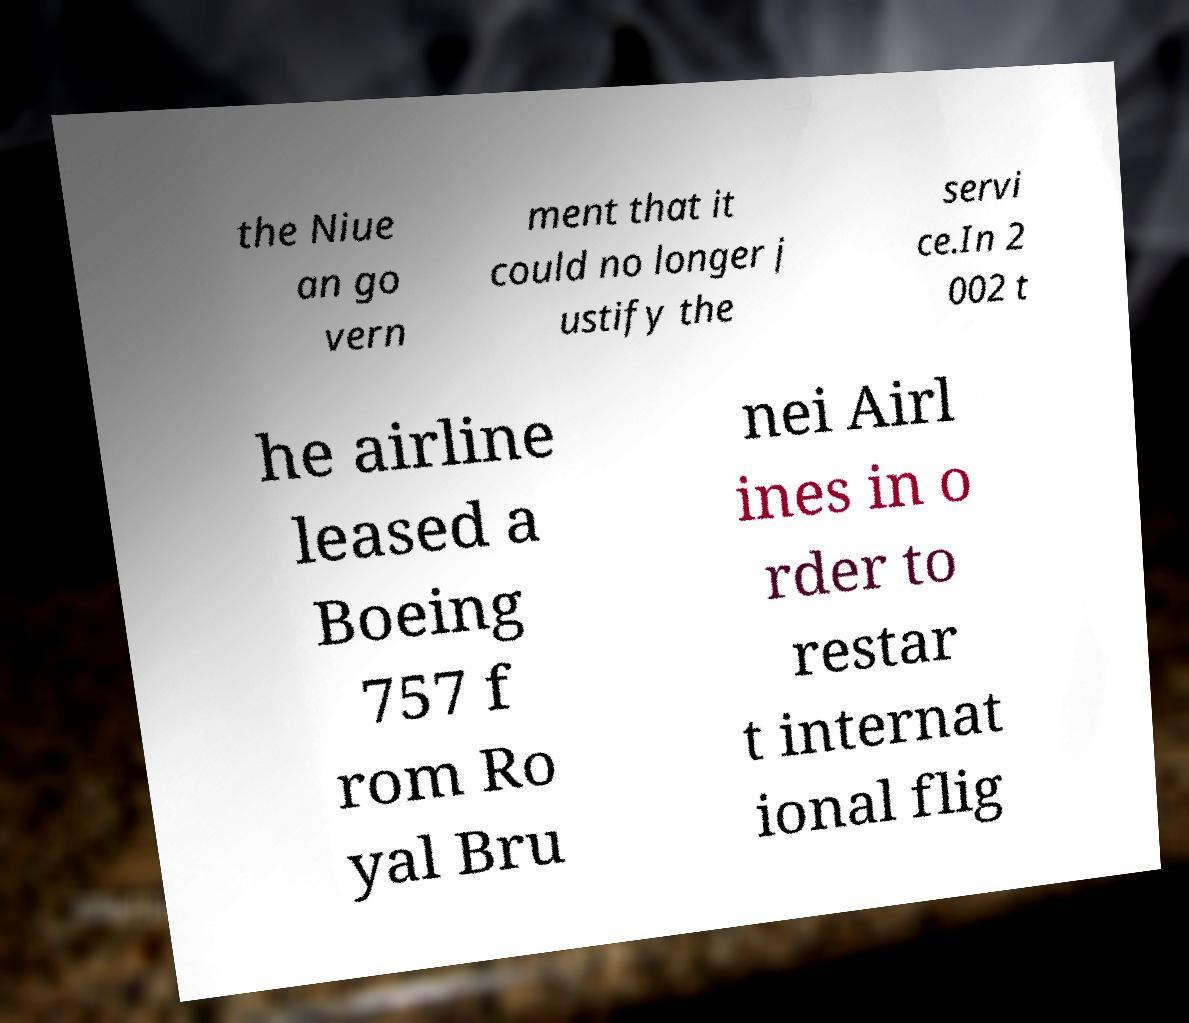Could you extract and type out the text from this image? the Niue an go vern ment that it could no longer j ustify the servi ce.In 2 002 t he airline leased a Boeing 757 f rom Ro yal Bru nei Airl ines in o rder to restar t internat ional flig 